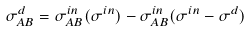Convert formula to latex. <formula><loc_0><loc_0><loc_500><loc_500>\sigma _ { A B } ^ { d } = \sigma _ { A B } ^ { i n } ( \sigma ^ { i n } ) - \sigma _ { A B } ^ { i n } ( \sigma ^ { i n } - \sigma ^ { d } )</formula> 